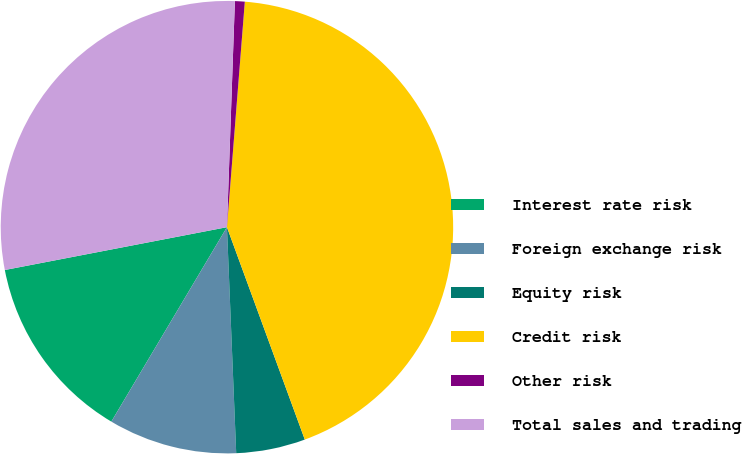Convert chart. <chart><loc_0><loc_0><loc_500><loc_500><pie_chart><fcel>Interest rate risk<fcel>Foreign exchange risk<fcel>Equity risk<fcel>Credit risk<fcel>Other risk<fcel>Total sales and trading<nl><fcel>13.43%<fcel>9.19%<fcel>4.94%<fcel>43.15%<fcel>0.7%<fcel>28.59%<nl></chart> 